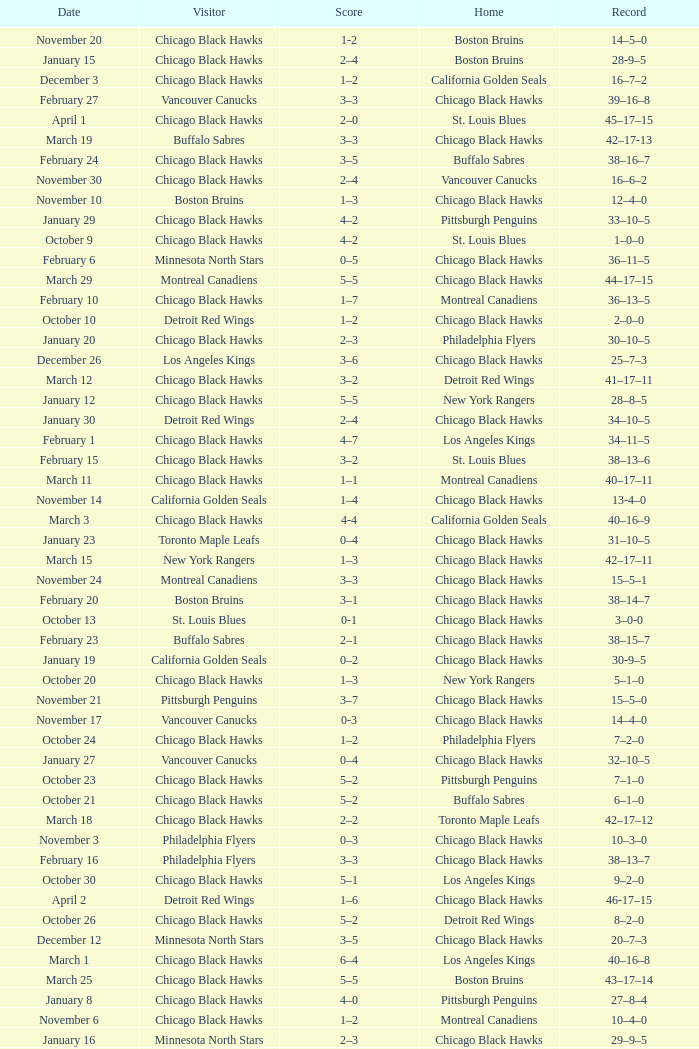What is the Score of the Chicago Black Hawks Home game with the Visiting Vancouver Canucks on November 17? 0-3. 